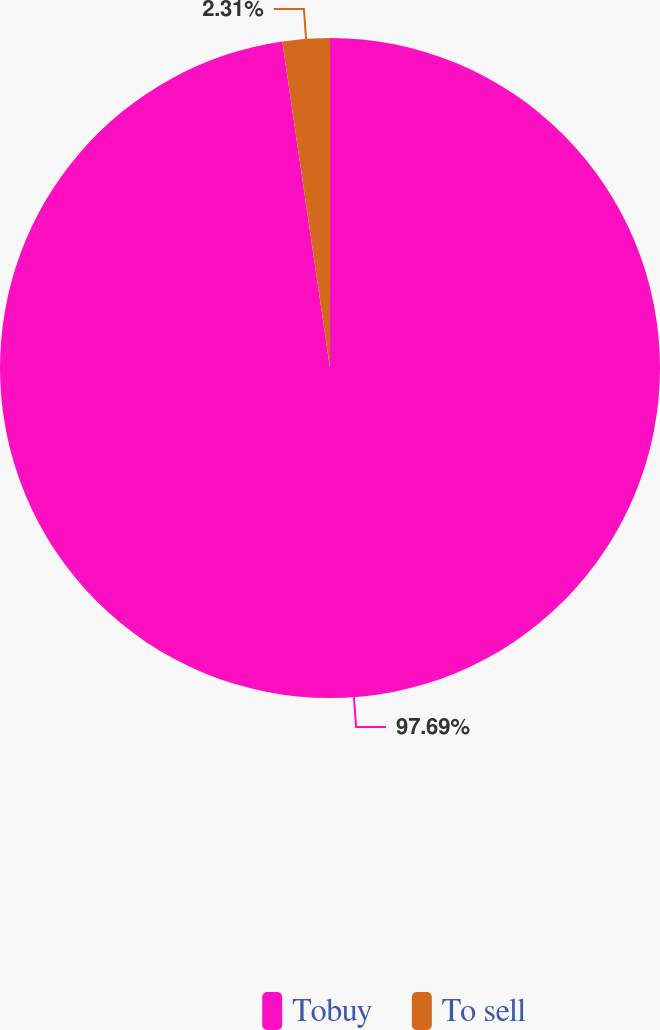<chart> <loc_0><loc_0><loc_500><loc_500><pie_chart><fcel>Tobuy<fcel>To sell<nl><fcel>97.69%<fcel>2.31%<nl></chart> 